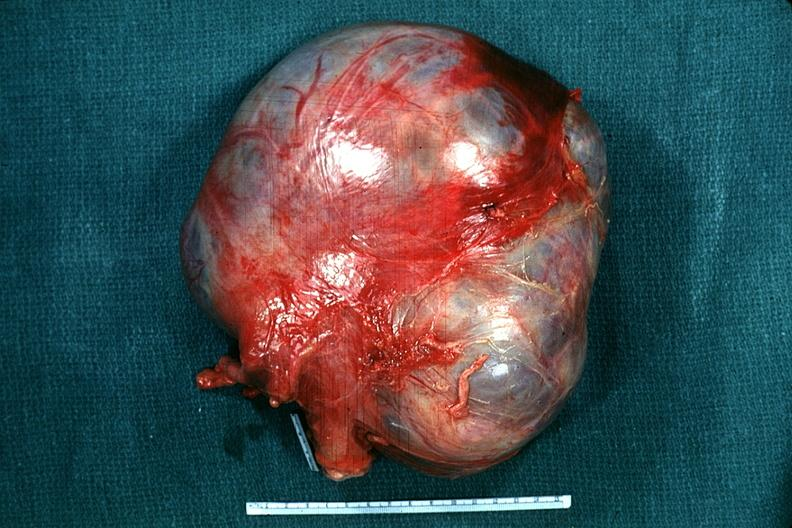s hand present?
Answer the question using a single word or phrase. No 